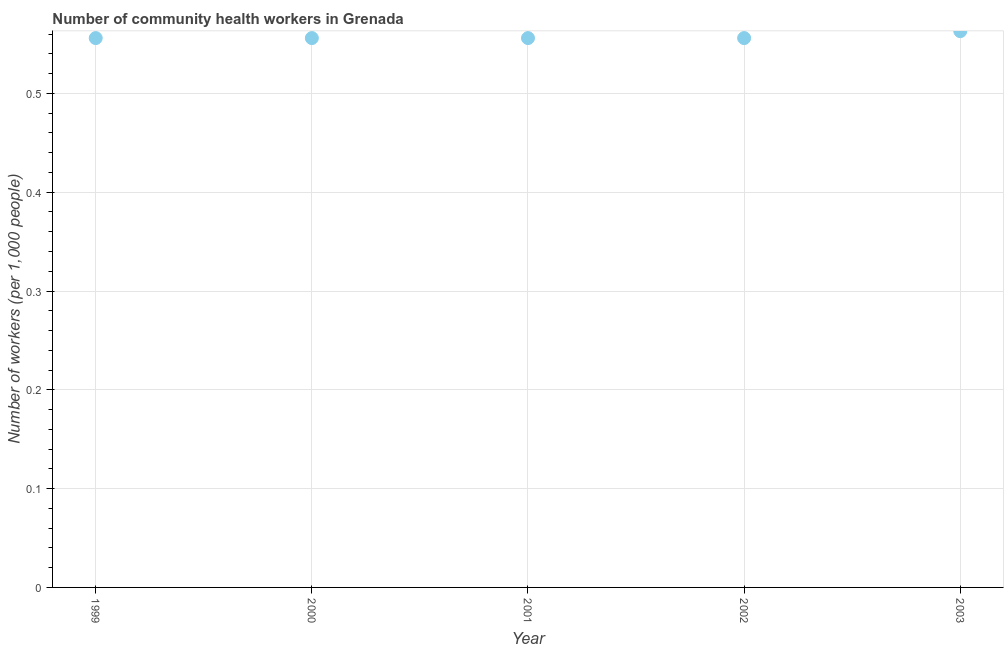What is the number of community health workers in 2003?
Offer a very short reply. 0.56. Across all years, what is the maximum number of community health workers?
Provide a succinct answer. 0.56. Across all years, what is the minimum number of community health workers?
Your answer should be compact. 0.56. What is the sum of the number of community health workers?
Ensure brevity in your answer.  2.79. What is the average number of community health workers per year?
Your response must be concise. 0.56. What is the median number of community health workers?
Provide a short and direct response. 0.56. In how many years, is the number of community health workers greater than 0.1 ?
Provide a short and direct response. 5. What is the ratio of the number of community health workers in 2000 to that in 2003?
Your response must be concise. 0.99. Is the difference between the number of community health workers in 1999 and 2000 greater than the difference between any two years?
Make the answer very short. No. What is the difference between the highest and the second highest number of community health workers?
Keep it short and to the point. 0.01. What is the difference between the highest and the lowest number of community health workers?
Keep it short and to the point. 0.01. In how many years, is the number of community health workers greater than the average number of community health workers taken over all years?
Your response must be concise. 1. Does the number of community health workers monotonically increase over the years?
Provide a succinct answer. No. How many years are there in the graph?
Ensure brevity in your answer.  5. Does the graph contain any zero values?
Make the answer very short. No. What is the title of the graph?
Provide a short and direct response. Number of community health workers in Grenada. What is the label or title of the Y-axis?
Make the answer very short. Number of workers (per 1,0 people). What is the Number of workers (per 1,000 people) in 1999?
Ensure brevity in your answer.  0.56. What is the Number of workers (per 1,000 people) in 2000?
Your response must be concise. 0.56. What is the Number of workers (per 1,000 people) in 2001?
Your answer should be very brief. 0.56. What is the Number of workers (per 1,000 people) in 2002?
Give a very brief answer. 0.56. What is the Number of workers (per 1,000 people) in 2003?
Offer a terse response. 0.56. What is the difference between the Number of workers (per 1,000 people) in 1999 and 2000?
Your answer should be very brief. 0. What is the difference between the Number of workers (per 1,000 people) in 1999 and 2002?
Offer a very short reply. 0. What is the difference between the Number of workers (per 1,000 people) in 1999 and 2003?
Offer a very short reply. -0.01. What is the difference between the Number of workers (per 1,000 people) in 2000 and 2003?
Give a very brief answer. -0.01. What is the difference between the Number of workers (per 1,000 people) in 2001 and 2003?
Your response must be concise. -0.01. What is the difference between the Number of workers (per 1,000 people) in 2002 and 2003?
Offer a terse response. -0.01. What is the ratio of the Number of workers (per 1,000 people) in 1999 to that in 2002?
Provide a succinct answer. 1. What is the ratio of the Number of workers (per 1,000 people) in 1999 to that in 2003?
Give a very brief answer. 0.99. What is the ratio of the Number of workers (per 1,000 people) in 2000 to that in 2001?
Provide a succinct answer. 1. What is the ratio of the Number of workers (per 1,000 people) in 2000 to that in 2002?
Ensure brevity in your answer.  1. What is the ratio of the Number of workers (per 1,000 people) in 2000 to that in 2003?
Provide a succinct answer. 0.99. What is the ratio of the Number of workers (per 1,000 people) in 2001 to that in 2003?
Give a very brief answer. 0.99. What is the ratio of the Number of workers (per 1,000 people) in 2002 to that in 2003?
Your answer should be very brief. 0.99. 